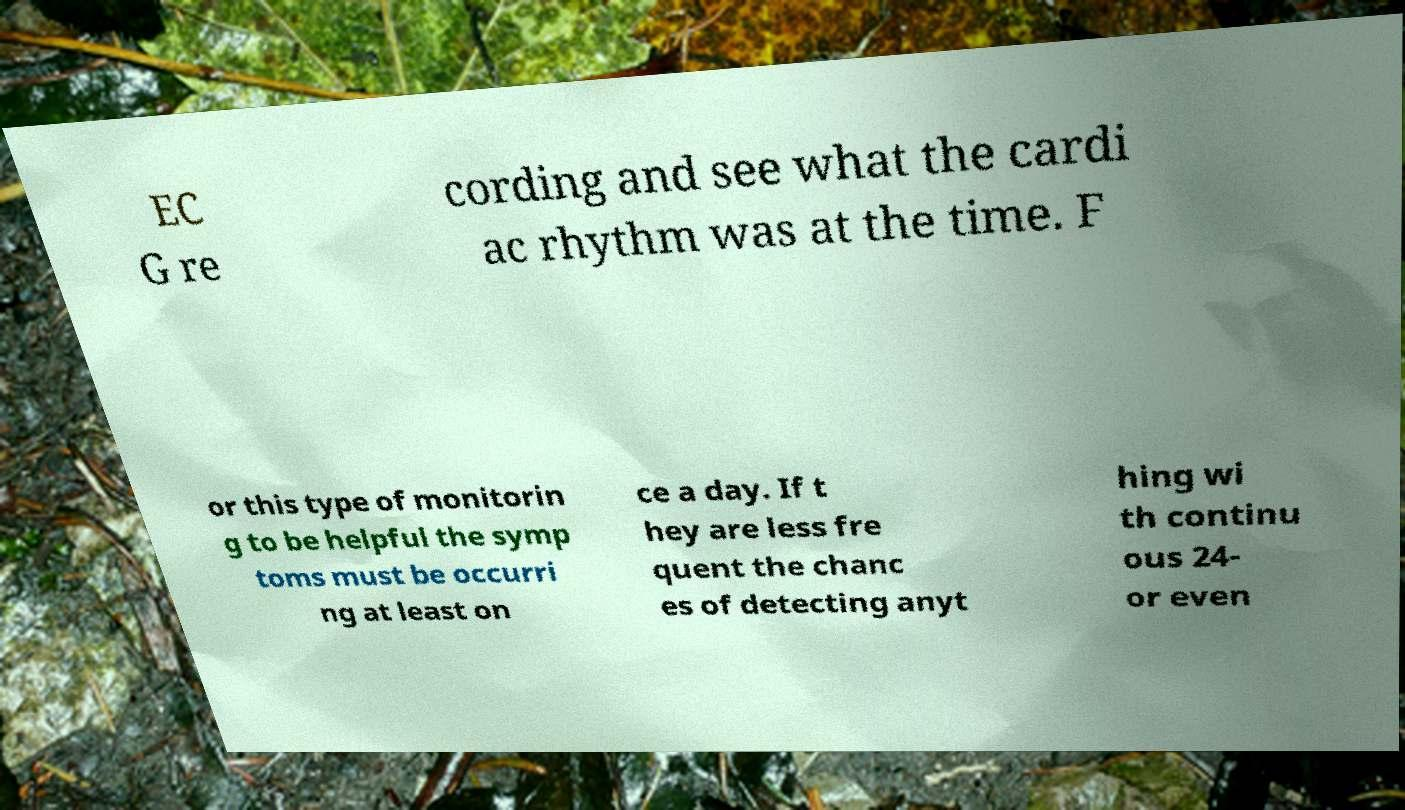Can you read and provide the text displayed in the image?This photo seems to have some interesting text. Can you extract and type it out for me? EC G re cording and see what the cardi ac rhythm was at the time. F or this type of monitorin g to be helpful the symp toms must be occurri ng at least on ce a day. If t hey are less fre quent the chanc es of detecting anyt hing wi th continu ous 24- or even 